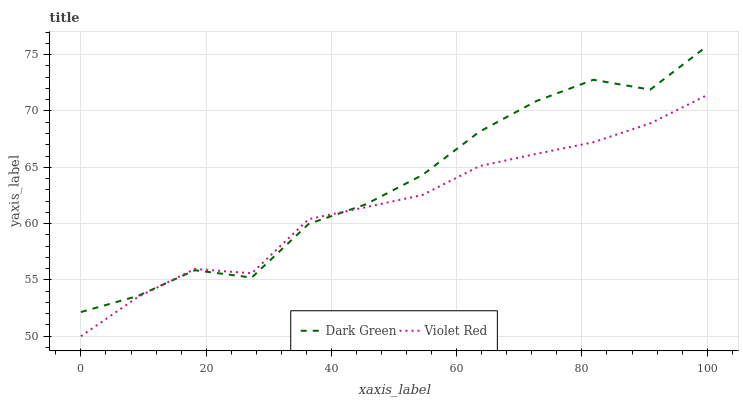Does Violet Red have the minimum area under the curve?
Answer yes or no. Yes. Does Dark Green have the minimum area under the curve?
Answer yes or no. No. Is Dark Green the smoothest?
Answer yes or no. No. Does Dark Green have the lowest value?
Answer yes or no. No. 